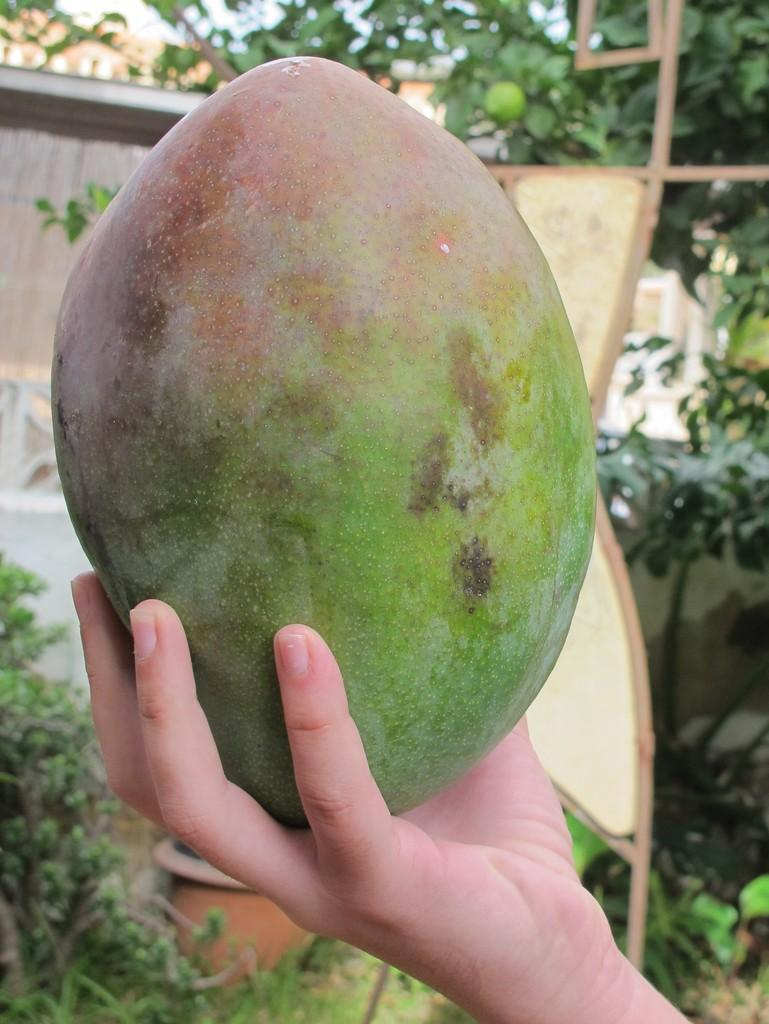What type of food can be seen in the image? There is fruit in the image. How is the fruit being held in the image? The fruit is being held in a hand. Can you see a tray with the fruit on it in the image? There is no tray visible in the image; the fruit is being held in a hand. 